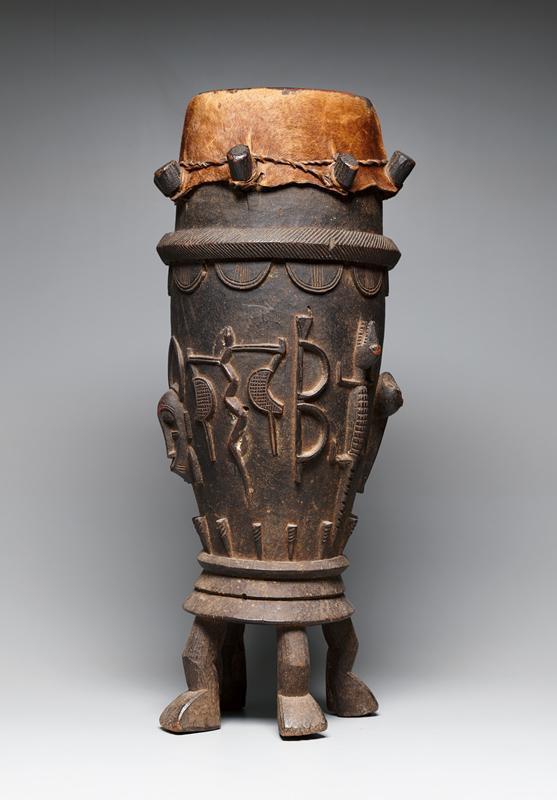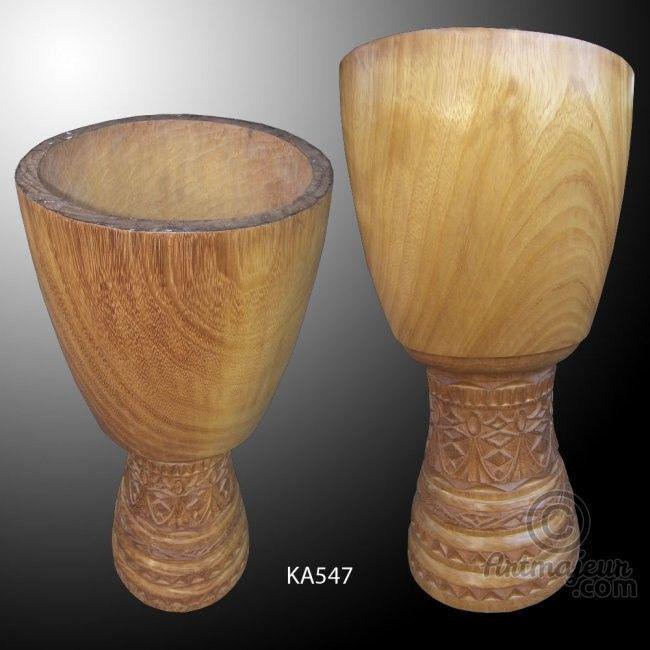The first image is the image on the left, the second image is the image on the right. Analyze the images presented: Is the assertion "There is a single drum in the left image and two drums in the right image." valid? Answer yes or no. Yes. The first image is the image on the left, the second image is the image on the right. Analyze the images presented: Is the assertion "In at least one image there are duel wooden drums." valid? Answer yes or no. Yes. 